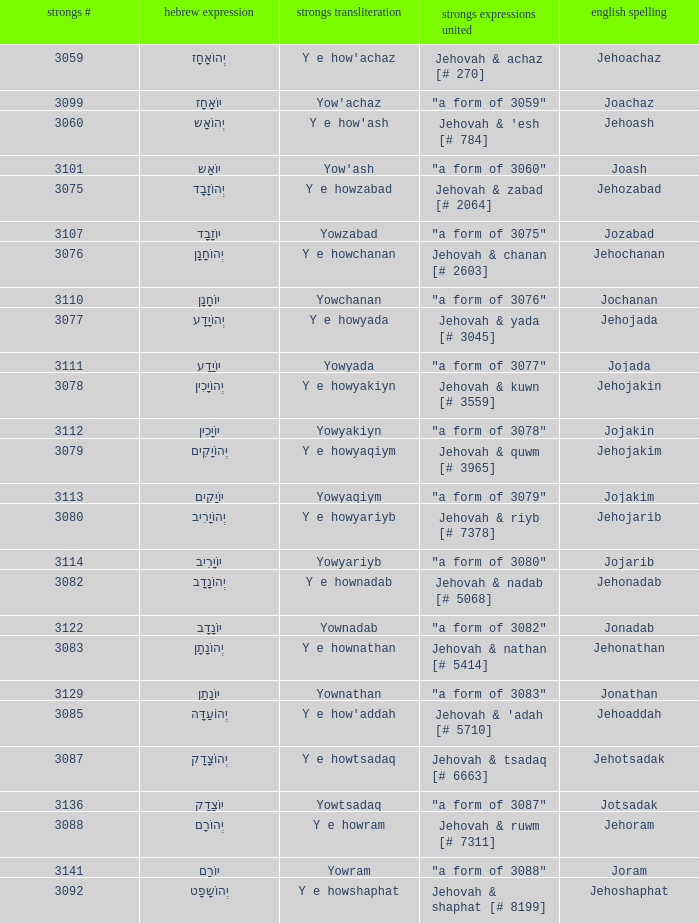How many strongs transliteration of the english spelling of the work jehojakin? 1.0. 